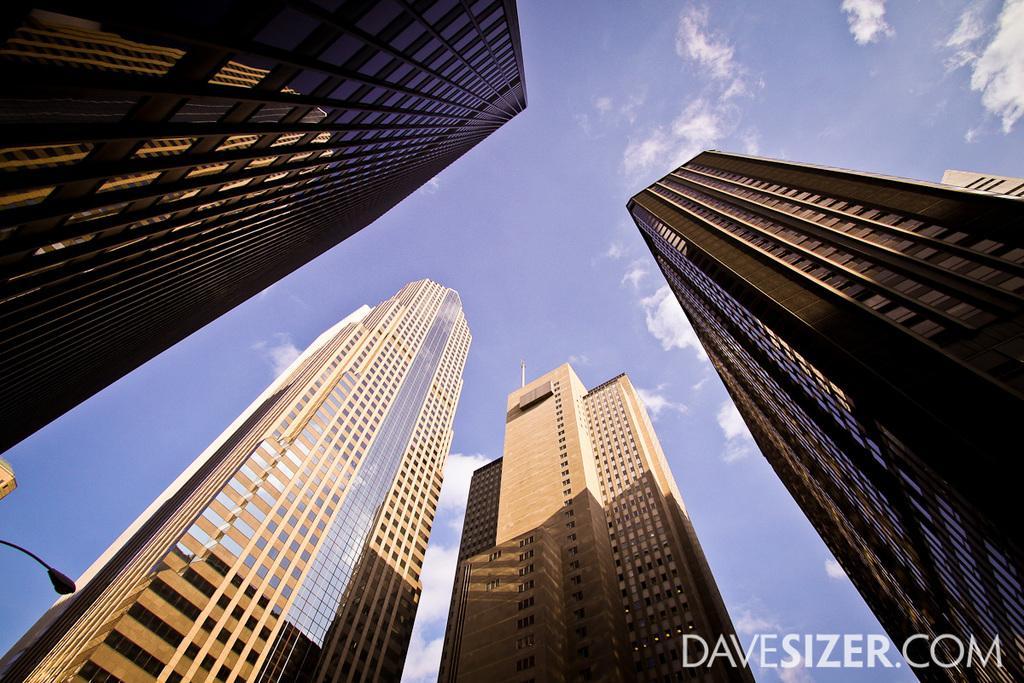Can you describe this image briefly? In this picture we can observe for tall buildings. On the left side there is a light pole. In the background there is a sky with clouds. 